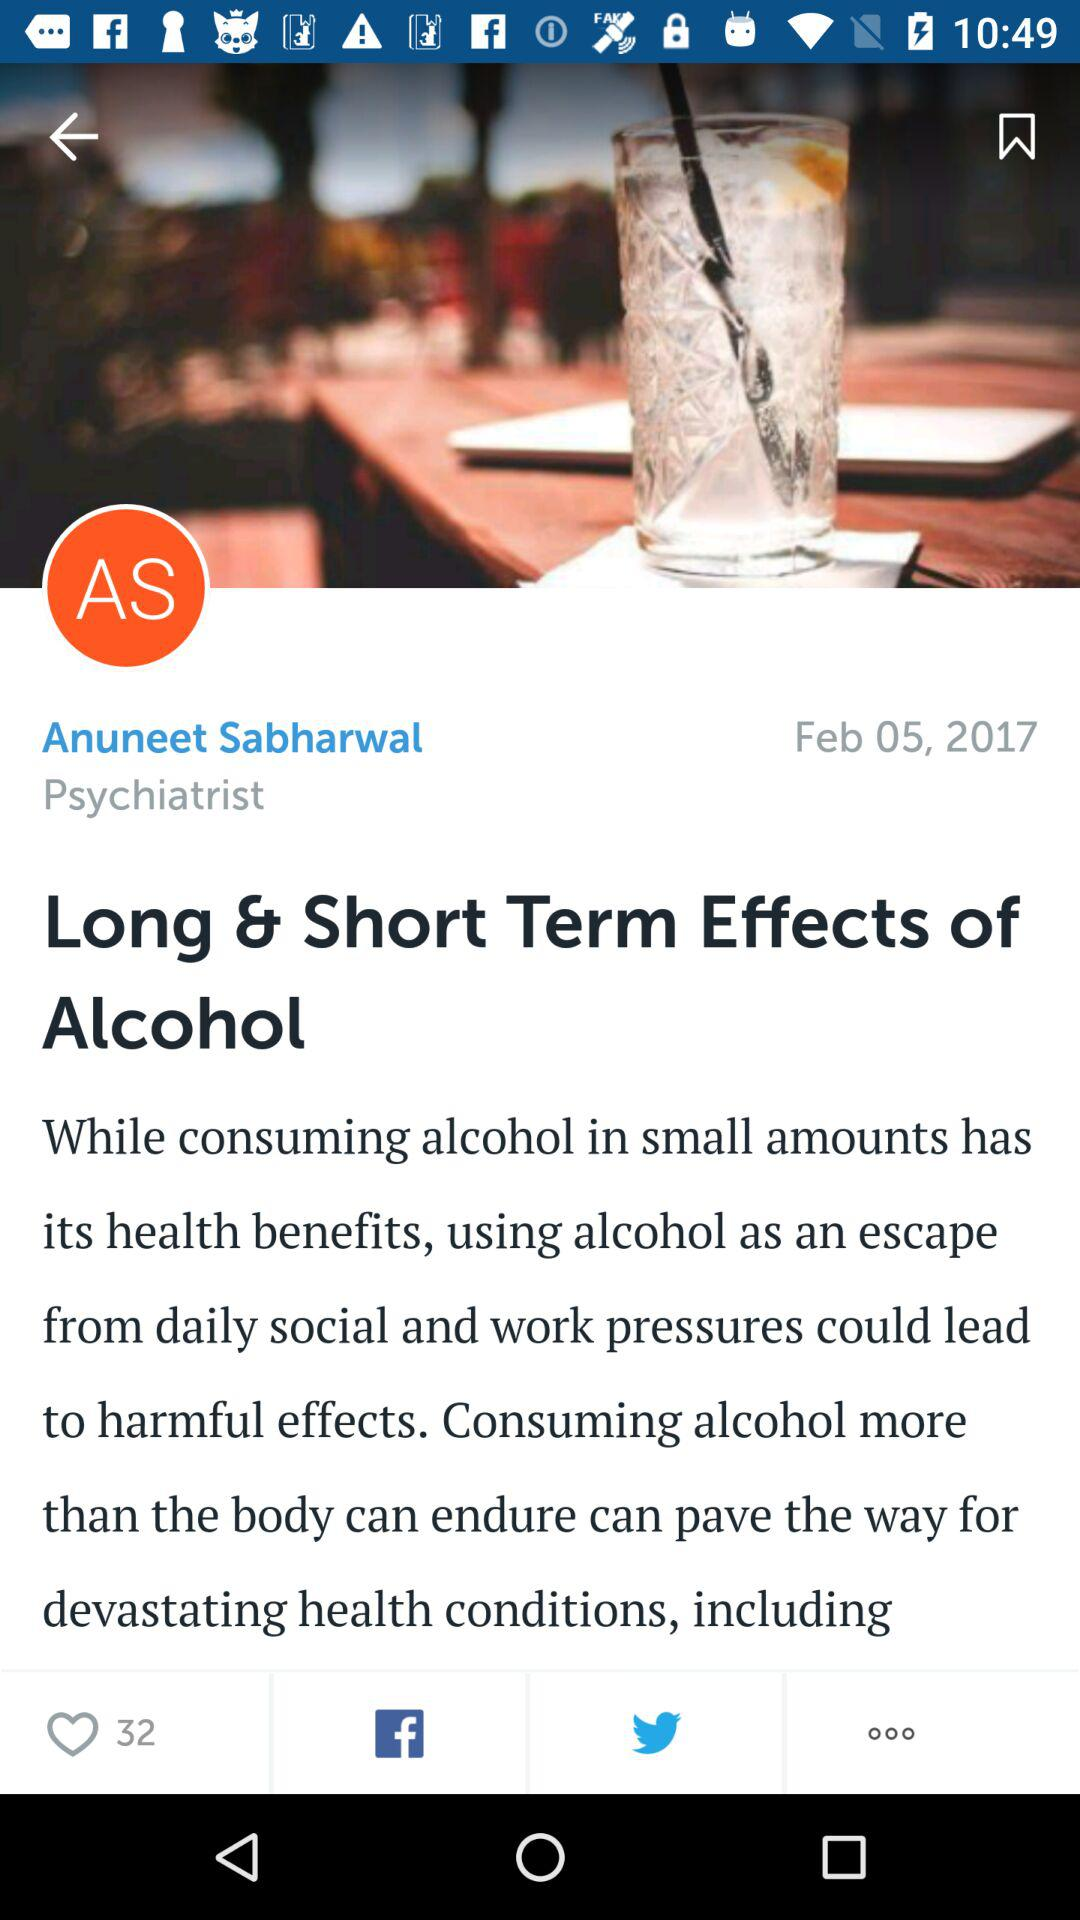What is the headline of the article? The headline is "Long & Short Term Effects of Alcohol". 